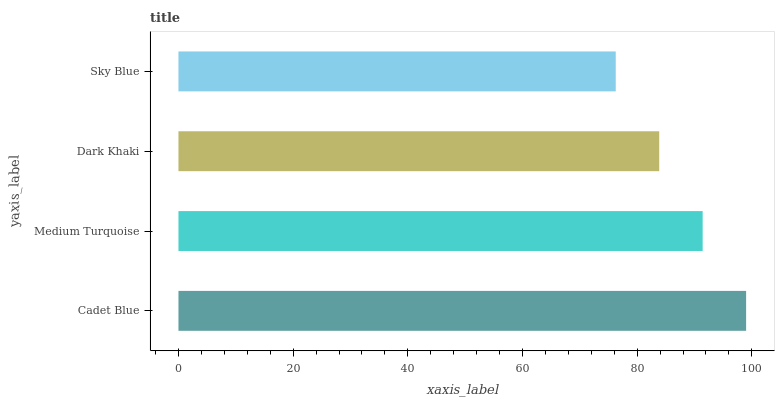Is Sky Blue the minimum?
Answer yes or no. Yes. Is Cadet Blue the maximum?
Answer yes or no. Yes. Is Medium Turquoise the minimum?
Answer yes or no. No. Is Medium Turquoise the maximum?
Answer yes or no. No. Is Cadet Blue greater than Medium Turquoise?
Answer yes or no. Yes. Is Medium Turquoise less than Cadet Blue?
Answer yes or no. Yes. Is Medium Turquoise greater than Cadet Blue?
Answer yes or no. No. Is Cadet Blue less than Medium Turquoise?
Answer yes or no. No. Is Medium Turquoise the high median?
Answer yes or no. Yes. Is Dark Khaki the low median?
Answer yes or no. Yes. Is Dark Khaki the high median?
Answer yes or no. No. Is Sky Blue the low median?
Answer yes or no. No. 